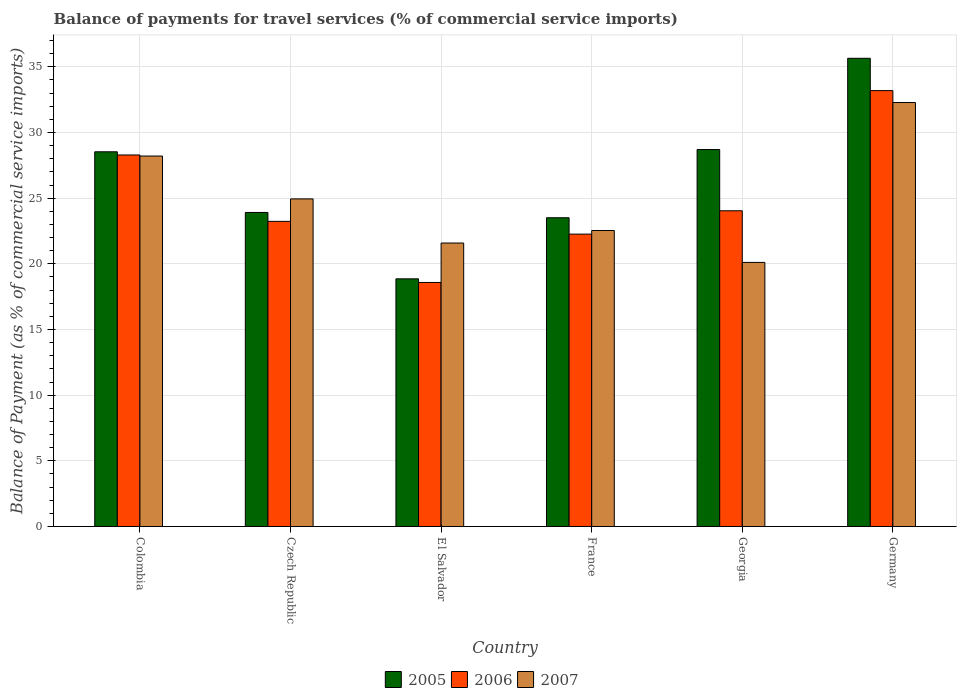How many different coloured bars are there?
Keep it short and to the point. 3. Are the number of bars per tick equal to the number of legend labels?
Provide a succinct answer. Yes. Are the number of bars on each tick of the X-axis equal?
Give a very brief answer. Yes. How many bars are there on the 3rd tick from the left?
Your response must be concise. 3. How many bars are there on the 3rd tick from the right?
Keep it short and to the point. 3. What is the label of the 3rd group of bars from the left?
Make the answer very short. El Salvador. What is the balance of payments for travel services in 2007 in Colombia?
Keep it short and to the point. 28.21. Across all countries, what is the maximum balance of payments for travel services in 2006?
Your answer should be compact. 33.19. Across all countries, what is the minimum balance of payments for travel services in 2005?
Ensure brevity in your answer.  18.86. In which country was the balance of payments for travel services in 2006 minimum?
Offer a terse response. El Salvador. What is the total balance of payments for travel services in 2005 in the graph?
Give a very brief answer. 159.16. What is the difference between the balance of payments for travel services in 2007 in France and that in Germany?
Provide a short and direct response. -9.75. What is the difference between the balance of payments for travel services in 2006 in Georgia and the balance of payments for travel services in 2005 in El Salvador?
Provide a short and direct response. 5.18. What is the average balance of payments for travel services in 2005 per country?
Your answer should be compact. 26.53. What is the difference between the balance of payments for travel services of/in 2007 and balance of payments for travel services of/in 2006 in El Salvador?
Your answer should be compact. 3. In how many countries, is the balance of payments for travel services in 2005 greater than 14 %?
Provide a succinct answer. 6. What is the ratio of the balance of payments for travel services in 2006 in Czech Republic to that in El Salvador?
Offer a terse response. 1.25. Is the difference between the balance of payments for travel services in 2007 in Colombia and El Salvador greater than the difference between the balance of payments for travel services in 2006 in Colombia and El Salvador?
Offer a very short reply. No. What is the difference between the highest and the second highest balance of payments for travel services in 2007?
Keep it short and to the point. 7.34. What is the difference between the highest and the lowest balance of payments for travel services in 2005?
Give a very brief answer. 16.79. In how many countries, is the balance of payments for travel services in 2005 greater than the average balance of payments for travel services in 2005 taken over all countries?
Your answer should be compact. 3. What does the 1st bar from the left in Germany represents?
Offer a terse response. 2005. Is it the case that in every country, the sum of the balance of payments for travel services in 2006 and balance of payments for travel services in 2007 is greater than the balance of payments for travel services in 2005?
Your answer should be compact. Yes. Are all the bars in the graph horizontal?
Offer a very short reply. No. What is the difference between two consecutive major ticks on the Y-axis?
Ensure brevity in your answer.  5. Are the values on the major ticks of Y-axis written in scientific E-notation?
Ensure brevity in your answer.  No. Does the graph contain any zero values?
Your answer should be very brief. No. What is the title of the graph?
Provide a short and direct response. Balance of payments for travel services (% of commercial service imports). What is the label or title of the X-axis?
Your response must be concise. Country. What is the label or title of the Y-axis?
Give a very brief answer. Balance of Payment (as % of commercial service imports). What is the Balance of Payment (as % of commercial service imports) of 2005 in Colombia?
Your answer should be very brief. 28.53. What is the Balance of Payment (as % of commercial service imports) in 2006 in Colombia?
Keep it short and to the point. 28.29. What is the Balance of Payment (as % of commercial service imports) in 2007 in Colombia?
Provide a short and direct response. 28.21. What is the Balance of Payment (as % of commercial service imports) of 2005 in Czech Republic?
Give a very brief answer. 23.91. What is the Balance of Payment (as % of commercial service imports) in 2006 in Czech Republic?
Keep it short and to the point. 23.24. What is the Balance of Payment (as % of commercial service imports) of 2007 in Czech Republic?
Make the answer very short. 24.94. What is the Balance of Payment (as % of commercial service imports) of 2005 in El Salvador?
Offer a very short reply. 18.86. What is the Balance of Payment (as % of commercial service imports) in 2006 in El Salvador?
Offer a terse response. 18.58. What is the Balance of Payment (as % of commercial service imports) of 2007 in El Salvador?
Keep it short and to the point. 21.59. What is the Balance of Payment (as % of commercial service imports) in 2005 in France?
Offer a terse response. 23.51. What is the Balance of Payment (as % of commercial service imports) of 2006 in France?
Your answer should be compact. 22.26. What is the Balance of Payment (as % of commercial service imports) in 2007 in France?
Your answer should be very brief. 22.54. What is the Balance of Payment (as % of commercial service imports) of 2005 in Georgia?
Provide a short and direct response. 28.7. What is the Balance of Payment (as % of commercial service imports) in 2006 in Georgia?
Offer a very short reply. 24.04. What is the Balance of Payment (as % of commercial service imports) of 2007 in Georgia?
Offer a very short reply. 20.11. What is the Balance of Payment (as % of commercial service imports) of 2005 in Germany?
Give a very brief answer. 35.65. What is the Balance of Payment (as % of commercial service imports) in 2006 in Germany?
Make the answer very short. 33.19. What is the Balance of Payment (as % of commercial service imports) in 2007 in Germany?
Your answer should be compact. 32.28. Across all countries, what is the maximum Balance of Payment (as % of commercial service imports) of 2005?
Offer a very short reply. 35.65. Across all countries, what is the maximum Balance of Payment (as % of commercial service imports) of 2006?
Your answer should be compact. 33.19. Across all countries, what is the maximum Balance of Payment (as % of commercial service imports) of 2007?
Offer a very short reply. 32.28. Across all countries, what is the minimum Balance of Payment (as % of commercial service imports) of 2005?
Give a very brief answer. 18.86. Across all countries, what is the minimum Balance of Payment (as % of commercial service imports) in 2006?
Give a very brief answer. 18.58. Across all countries, what is the minimum Balance of Payment (as % of commercial service imports) in 2007?
Provide a succinct answer. 20.11. What is the total Balance of Payment (as % of commercial service imports) of 2005 in the graph?
Offer a terse response. 159.16. What is the total Balance of Payment (as % of commercial service imports) of 2006 in the graph?
Provide a succinct answer. 149.6. What is the total Balance of Payment (as % of commercial service imports) in 2007 in the graph?
Keep it short and to the point. 149.67. What is the difference between the Balance of Payment (as % of commercial service imports) of 2005 in Colombia and that in Czech Republic?
Your answer should be very brief. 4.62. What is the difference between the Balance of Payment (as % of commercial service imports) of 2006 in Colombia and that in Czech Republic?
Offer a terse response. 5.05. What is the difference between the Balance of Payment (as % of commercial service imports) in 2007 in Colombia and that in Czech Republic?
Make the answer very short. 3.26. What is the difference between the Balance of Payment (as % of commercial service imports) of 2005 in Colombia and that in El Salvador?
Give a very brief answer. 9.67. What is the difference between the Balance of Payment (as % of commercial service imports) in 2006 in Colombia and that in El Salvador?
Keep it short and to the point. 9.71. What is the difference between the Balance of Payment (as % of commercial service imports) of 2007 in Colombia and that in El Salvador?
Your answer should be very brief. 6.62. What is the difference between the Balance of Payment (as % of commercial service imports) of 2005 in Colombia and that in France?
Offer a very short reply. 5.02. What is the difference between the Balance of Payment (as % of commercial service imports) of 2006 in Colombia and that in France?
Your answer should be compact. 6.03. What is the difference between the Balance of Payment (as % of commercial service imports) of 2007 in Colombia and that in France?
Your answer should be compact. 5.67. What is the difference between the Balance of Payment (as % of commercial service imports) in 2005 in Colombia and that in Georgia?
Keep it short and to the point. -0.17. What is the difference between the Balance of Payment (as % of commercial service imports) in 2006 in Colombia and that in Georgia?
Offer a very short reply. 4.25. What is the difference between the Balance of Payment (as % of commercial service imports) of 2007 in Colombia and that in Georgia?
Ensure brevity in your answer.  8.1. What is the difference between the Balance of Payment (as % of commercial service imports) in 2005 in Colombia and that in Germany?
Make the answer very short. -7.12. What is the difference between the Balance of Payment (as % of commercial service imports) in 2006 in Colombia and that in Germany?
Your response must be concise. -4.9. What is the difference between the Balance of Payment (as % of commercial service imports) in 2007 in Colombia and that in Germany?
Make the answer very short. -4.08. What is the difference between the Balance of Payment (as % of commercial service imports) of 2005 in Czech Republic and that in El Salvador?
Make the answer very short. 5.05. What is the difference between the Balance of Payment (as % of commercial service imports) in 2006 in Czech Republic and that in El Salvador?
Provide a short and direct response. 4.65. What is the difference between the Balance of Payment (as % of commercial service imports) of 2007 in Czech Republic and that in El Salvador?
Provide a short and direct response. 3.36. What is the difference between the Balance of Payment (as % of commercial service imports) of 2005 in Czech Republic and that in France?
Keep it short and to the point. 0.4. What is the difference between the Balance of Payment (as % of commercial service imports) in 2006 in Czech Republic and that in France?
Offer a terse response. 0.97. What is the difference between the Balance of Payment (as % of commercial service imports) in 2007 in Czech Republic and that in France?
Keep it short and to the point. 2.41. What is the difference between the Balance of Payment (as % of commercial service imports) of 2005 in Czech Republic and that in Georgia?
Your answer should be very brief. -4.79. What is the difference between the Balance of Payment (as % of commercial service imports) in 2006 in Czech Republic and that in Georgia?
Your answer should be compact. -0.8. What is the difference between the Balance of Payment (as % of commercial service imports) of 2007 in Czech Republic and that in Georgia?
Offer a terse response. 4.84. What is the difference between the Balance of Payment (as % of commercial service imports) in 2005 in Czech Republic and that in Germany?
Offer a very short reply. -11.74. What is the difference between the Balance of Payment (as % of commercial service imports) in 2006 in Czech Republic and that in Germany?
Your answer should be very brief. -9.96. What is the difference between the Balance of Payment (as % of commercial service imports) of 2007 in Czech Republic and that in Germany?
Keep it short and to the point. -7.34. What is the difference between the Balance of Payment (as % of commercial service imports) in 2005 in El Salvador and that in France?
Provide a succinct answer. -4.65. What is the difference between the Balance of Payment (as % of commercial service imports) in 2006 in El Salvador and that in France?
Your response must be concise. -3.68. What is the difference between the Balance of Payment (as % of commercial service imports) of 2007 in El Salvador and that in France?
Give a very brief answer. -0.95. What is the difference between the Balance of Payment (as % of commercial service imports) in 2005 in El Salvador and that in Georgia?
Give a very brief answer. -9.85. What is the difference between the Balance of Payment (as % of commercial service imports) of 2006 in El Salvador and that in Georgia?
Offer a very short reply. -5.46. What is the difference between the Balance of Payment (as % of commercial service imports) of 2007 in El Salvador and that in Georgia?
Offer a terse response. 1.48. What is the difference between the Balance of Payment (as % of commercial service imports) in 2005 in El Salvador and that in Germany?
Offer a very short reply. -16.79. What is the difference between the Balance of Payment (as % of commercial service imports) in 2006 in El Salvador and that in Germany?
Ensure brevity in your answer.  -14.61. What is the difference between the Balance of Payment (as % of commercial service imports) in 2007 in El Salvador and that in Germany?
Your answer should be very brief. -10.7. What is the difference between the Balance of Payment (as % of commercial service imports) of 2005 in France and that in Georgia?
Keep it short and to the point. -5.19. What is the difference between the Balance of Payment (as % of commercial service imports) in 2006 in France and that in Georgia?
Provide a succinct answer. -1.78. What is the difference between the Balance of Payment (as % of commercial service imports) in 2007 in France and that in Georgia?
Your response must be concise. 2.43. What is the difference between the Balance of Payment (as % of commercial service imports) in 2005 in France and that in Germany?
Provide a succinct answer. -12.14. What is the difference between the Balance of Payment (as % of commercial service imports) in 2006 in France and that in Germany?
Provide a succinct answer. -10.93. What is the difference between the Balance of Payment (as % of commercial service imports) of 2007 in France and that in Germany?
Your response must be concise. -9.75. What is the difference between the Balance of Payment (as % of commercial service imports) of 2005 in Georgia and that in Germany?
Give a very brief answer. -6.95. What is the difference between the Balance of Payment (as % of commercial service imports) in 2006 in Georgia and that in Germany?
Your answer should be compact. -9.15. What is the difference between the Balance of Payment (as % of commercial service imports) of 2007 in Georgia and that in Germany?
Your answer should be very brief. -12.18. What is the difference between the Balance of Payment (as % of commercial service imports) in 2005 in Colombia and the Balance of Payment (as % of commercial service imports) in 2006 in Czech Republic?
Offer a terse response. 5.3. What is the difference between the Balance of Payment (as % of commercial service imports) of 2005 in Colombia and the Balance of Payment (as % of commercial service imports) of 2007 in Czech Republic?
Your response must be concise. 3.59. What is the difference between the Balance of Payment (as % of commercial service imports) of 2006 in Colombia and the Balance of Payment (as % of commercial service imports) of 2007 in Czech Republic?
Keep it short and to the point. 3.34. What is the difference between the Balance of Payment (as % of commercial service imports) in 2005 in Colombia and the Balance of Payment (as % of commercial service imports) in 2006 in El Salvador?
Offer a terse response. 9.95. What is the difference between the Balance of Payment (as % of commercial service imports) in 2005 in Colombia and the Balance of Payment (as % of commercial service imports) in 2007 in El Salvador?
Offer a very short reply. 6.95. What is the difference between the Balance of Payment (as % of commercial service imports) of 2006 in Colombia and the Balance of Payment (as % of commercial service imports) of 2007 in El Salvador?
Ensure brevity in your answer.  6.7. What is the difference between the Balance of Payment (as % of commercial service imports) in 2005 in Colombia and the Balance of Payment (as % of commercial service imports) in 2006 in France?
Offer a terse response. 6.27. What is the difference between the Balance of Payment (as % of commercial service imports) in 2005 in Colombia and the Balance of Payment (as % of commercial service imports) in 2007 in France?
Give a very brief answer. 5.99. What is the difference between the Balance of Payment (as % of commercial service imports) in 2006 in Colombia and the Balance of Payment (as % of commercial service imports) in 2007 in France?
Offer a terse response. 5.75. What is the difference between the Balance of Payment (as % of commercial service imports) in 2005 in Colombia and the Balance of Payment (as % of commercial service imports) in 2006 in Georgia?
Make the answer very short. 4.49. What is the difference between the Balance of Payment (as % of commercial service imports) of 2005 in Colombia and the Balance of Payment (as % of commercial service imports) of 2007 in Georgia?
Make the answer very short. 8.42. What is the difference between the Balance of Payment (as % of commercial service imports) in 2006 in Colombia and the Balance of Payment (as % of commercial service imports) in 2007 in Georgia?
Ensure brevity in your answer.  8.18. What is the difference between the Balance of Payment (as % of commercial service imports) in 2005 in Colombia and the Balance of Payment (as % of commercial service imports) in 2006 in Germany?
Make the answer very short. -4.66. What is the difference between the Balance of Payment (as % of commercial service imports) of 2005 in Colombia and the Balance of Payment (as % of commercial service imports) of 2007 in Germany?
Keep it short and to the point. -3.75. What is the difference between the Balance of Payment (as % of commercial service imports) in 2006 in Colombia and the Balance of Payment (as % of commercial service imports) in 2007 in Germany?
Provide a succinct answer. -3.99. What is the difference between the Balance of Payment (as % of commercial service imports) in 2005 in Czech Republic and the Balance of Payment (as % of commercial service imports) in 2006 in El Salvador?
Your answer should be compact. 5.33. What is the difference between the Balance of Payment (as % of commercial service imports) in 2005 in Czech Republic and the Balance of Payment (as % of commercial service imports) in 2007 in El Salvador?
Provide a succinct answer. 2.33. What is the difference between the Balance of Payment (as % of commercial service imports) in 2006 in Czech Republic and the Balance of Payment (as % of commercial service imports) in 2007 in El Salvador?
Provide a short and direct response. 1.65. What is the difference between the Balance of Payment (as % of commercial service imports) of 2005 in Czech Republic and the Balance of Payment (as % of commercial service imports) of 2006 in France?
Provide a short and direct response. 1.65. What is the difference between the Balance of Payment (as % of commercial service imports) in 2005 in Czech Republic and the Balance of Payment (as % of commercial service imports) in 2007 in France?
Give a very brief answer. 1.37. What is the difference between the Balance of Payment (as % of commercial service imports) in 2006 in Czech Republic and the Balance of Payment (as % of commercial service imports) in 2007 in France?
Make the answer very short. 0.7. What is the difference between the Balance of Payment (as % of commercial service imports) of 2005 in Czech Republic and the Balance of Payment (as % of commercial service imports) of 2006 in Georgia?
Your answer should be compact. -0.13. What is the difference between the Balance of Payment (as % of commercial service imports) in 2005 in Czech Republic and the Balance of Payment (as % of commercial service imports) in 2007 in Georgia?
Keep it short and to the point. 3.8. What is the difference between the Balance of Payment (as % of commercial service imports) of 2006 in Czech Republic and the Balance of Payment (as % of commercial service imports) of 2007 in Georgia?
Your response must be concise. 3.13. What is the difference between the Balance of Payment (as % of commercial service imports) in 2005 in Czech Republic and the Balance of Payment (as % of commercial service imports) in 2006 in Germany?
Make the answer very short. -9.28. What is the difference between the Balance of Payment (as % of commercial service imports) in 2005 in Czech Republic and the Balance of Payment (as % of commercial service imports) in 2007 in Germany?
Your answer should be compact. -8.37. What is the difference between the Balance of Payment (as % of commercial service imports) of 2006 in Czech Republic and the Balance of Payment (as % of commercial service imports) of 2007 in Germany?
Provide a short and direct response. -9.05. What is the difference between the Balance of Payment (as % of commercial service imports) in 2005 in El Salvador and the Balance of Payment (as % of commercial service imports) in 2006 in France?
Make the answer very short. -3.41. What is the difference between the Balance of Payment (as % of commercial service imports) in 2005 in El Salvador and the Balance of Payment (as % of commercial service imports) in 2007 in France?
Your response must be concise. -3.68. What is the difference between the Balance of Payment (as % of commercial service imports) in 2006 in El Salvador and the Balance of Payment (as % of commercial service imports) in 2007 in France?
Your answer should be very brief. -3.96. What is the difference between the Balance of Payment (as % of commercial service imports) of 2005 in El Salvador and the Balance of Payment (as % of commercial service imports) of 2006 in Georgia?
Your answer should be compact. -5.18. What is the difference between the Balance of Payment (as % of commercial service imports) in 2005 in El Salvador and the Balance of Payment (as % of commercial service imports) in 2007 in Georgia?
Make the answer very short. -1.25. What is the difference between the Balance of Payment (as % of commercial service imports) of 2006 in El Salvador and the Balance of Payment (as % of commercial service imports) of 2007 in Georgia?
Your answer should be compact. -1.53. What is the difference between the Balance of Payment (as % of commercial service imports) of 2005 in El Salvador and the Balance of Payment (as % of commercial service imports) of 2006 in Germany?
Offer a very short reply. -14.33. What is the difference between the Balance of Payment (as % of commercial service imports) of 2005 in El Salvador and the Balance of Payment (as % of commercial service imports) of 2007 in Germany?
Your response must be concise. -13.43. What is the difference between the Balance of Payment (as % of commercial service imports) in 2006 in El Salvador and the Balance of Payment (as % of commercial service imports) in 2007 in Germany?
Your answer should be very brief. -13.7. What is the difference between the Balance of Payment (as % of commercial service imports) in 2005 in France and the Balance of Payment (as % of commercial service imports) in 2006 in Georgia?
Ensure brevity in your answer.  -0.53. What is the difference between the Balance of Payment (as % of commercial service imports) of 2005 in France and the Balance of Payment (as % of commercial service imports) of 2007 in Georgia?
Offer a very short reply. 3.4. What is the difference between the Balance of Payment (as % of commercial service imports) in 2006 in France and the Balance of Payment (as % of commercial service imports) in 2007 in Georgia?
Your answer should be compact. 2.15. What is the difference between the Balance of Payment (as % of commercial service imports) of 2005 in France and the Balance of Payment (as % of commercial service imports) of 2006 in Germany?
Give a very brief answer. -9.68. What is the difference between the Balance of Payment (as % of commercial service imports) of 2005 in France and the Balance of Payment (as % of commercial service imports) of 2007 in Germany?
Keep it short and to the point. -8.77. What is the difference between the Balance of Payment (as % of commercial service imports) of 2006 in France and the Balance of Payment (as % of commercial service imports) of 2007 in Germany?
Your response must be concise. -10.02. What is the difference between the Balance of Payment (as % of commercial service imports) in 2005 in Georgia and the Balance of Payment (as % of commercial service imports) in 2006 in Germany?
Give a very brief answer. -4.49. What is the difference between the Balance of Payment (as % of commercial service imports) of 2005 in Georgia and the Balance of Payment (as % of commercial service imports) of 2007 in Germany?
Provide a succinct answer. -3.58. What is the difference between the Balance of Payment (as % of commercial service imports) in 2006 in Georgia and the Balance of Payment (as % of commercial service imports) in 2007 in Germany?
Offer a terse response. -8.24. What is the average Balance of Payment (as % of commercial service imports) of 2005 per country?
Your response must be concise. 26.53. What is the average Balance of Payment (as % of commercial service imports) in 2006 per country?
Keep it short and to the point. 24.93. What is the average Balance of Payment (as % of commercial service imports) in 2007 per country?
Your answer should be compact. 24.94. What is the difference between the Balance of Payment (as % of commercial service imports) of 2005 and Balance of Payment (as % of commercial service imports) of 2006 in Colombia?
Ensure brevity in your answer.  0.24. What is the difference between the Balance of Payment (as % of commercial service imports) in 2005 and Balance of Payment (as % of commercial service imports) in 2007 in Colombia?
Your answer should be compact. 0.32. What is the difference between the Balance of Payment (as % of commercial service imports) of 2006 and Balance of Payment (as % of commercial service imports) of 2007 in Colombia?
Your answer should be compact. 0.08. What is the difference between the Balance of Payment (as % of commercial service imports) in 2005 and Balance of Payment (as % of commercial service imports) in 2006 in Czech Republic?
Offer a terse response. 0.68. What is the difference between the Balance of Payment (as % of commercial service imports) in 2005 and Balance of Payment (as % of commercial service imports) in 2007 in Czech Republic?
Ensure brevity in your answer.  -1.03. What is the difference between the Balance of Payment (as % of commercial service imports) of 2006 and Balance of Payment (as % of commercial service imports) of 2007 in Czech Republic?
Offer a terse response. -1.71. What is the difference between the Balance of Payment (as % of commercial service imports) of 2005 and Balance of Payment (as % of commercial service imports) of 2006 in El Salvador?
Keep it short and to the point. 0.28. What is the difference between the Balance of Payment (as % of commercial service imports) of 2005 and Balance of Payment (as % of commercial service imports) of 2007 in El Salvador?
Your answer should be very brief. -2.73. What is the difference between the Balance of Payment (as % of commercial service imports) in 2006 and Balance of Payment (as % of commercial service imports) in 2007 in El Salvador?
Offer a very short reply. -3. What is the difference between the Balance of Payment (as % of commercial service imports) of 2005 and Balance of Payment (as % of commercial service imports) of 2006 in France?
Offer a terse response. 1.25. What is the difference between the Balance of Payment (as % of commercial service imports) of 2005 and Balance of Payment (as % of commercial service imports) of 2007 in France?
Ensure brevity in your answer.  0.97. What is the difference between the Balance of Payment (as % of commercial service imports) of 2006 and Balance of Payment (as % of commercial service imports) of 2007 in France?
Your answer should be compact. -0.27. What is the difference between the Balance of Payment (as % of commercial service imports) of 2005 and Balance of Payment (as % of commercial service imports) of 2006 in Georgia?
Your response must be concise. 4.66. What is the difference between the Balance of Payment (as % of commercial service imports) in 2005 and Balance of Payment (as % of commercial service imports) in 2007 in Georgia?
Keep it short and to the point. 8.59. What is the difference between the Balance of Payment (as % of commercial service imports) in 2006 and Balance of Payment (as % of commercial service imports) in 2007 in Georgia?
Make the answer very short. 3.93. What is the difference between the Balance of Payment (as % of commercial service imports) in 2005 and Balance of Payment (as % of commercial service imports) in 2006 in Germany?
Provide a succinct answer. 2.46. What is the difference between the Balance of Payment (as % of commercial service imports) of 2005 and Balance of Payment (as % of commercial service imports) of 2007 in Germany?
Offer a very short reply. 3.37. What is the difference between the Balance of Payment (as % of commercial service imports) in 2006 and Balance of Payment (as % of commercial service imports) in 2007 in Germany?
Ensure brevity in your answer.  0.91. What is the ratio of the Balance of Payment (as % of commercial service imports) of 2005 in Colombia to that in Czech Republic?
Provide a short and direct response. 1.19. What is the ratio of the Balance of Payment (as % of commercial service imports) in 2006 in Colombia to that in Czech Republic?
Offer a very short reply. 1.22. What is the ratio of the Balance of Payment (as % of commercial service imports) of 2007 in Colombia to that in Czech Republic?
Your response must be concise. 1.13. What is the ratio of the Balance of Payment (as % of commercial service imports) of 2005 in Colombia to that in El Salvador?
Your answer should be compact. 1.51. What is the ratio of the Balance of Payment (as % of commercial service imports) of 2006 in Colombia to that in El Salvador?
Give a very brief answer. 1.52. What is the ratio of the Balance of Payment (as % of commercial service imports) in 2007 in Colombia to that in El Salvador?
Provide a short and direct response. 1.31. What is the ratio of the Balance of Payment (as % of commercial service imports) of 2005 in Colombia to that in France?
Your answer should be very brief. 1.21. What is the ratio of the Balance of Payment (as % of commercial service imports) of 2006 in Colombia to that in France?
Your response must be concise. 1.27. What is the ratio of the Balance of Payment (as % of commercial service imports) in 2007 in Colombia to that in France?
Ensure brevity in your answer.  1.25. What is the ratio of the Balance of Payment (as % of commercial service imports) of 2005 in Colombia to that in Georgia?
Give a very brief answer. 0.99. What is the ratio of the Balance of Payment (as % of commercial service imports) in 2006 in Colombia to that in Georgia?
Provide a succinct answer. 1.18. What is the ratio of the Balance of Payment (as % of commercial service imports) in 2007 in Colombia to that in Georgia?
Offer a very short reply. 1.4. What is the ratio of the Balance of Payment (as % of commercial service imports) in 2005 in Colombia to that in Germany?
Offer a very short reply. 0.8. What is the ratio of the Balance of Payment (as % of commercial service imports) in 2006 in Colombia to that in Germany?
Ensure brevity in your answer.  0.85. What is the ratio of the Balance of Payment (as % of commercial service imports) of 2007 in Colombia to that in Germany?
Give a very brief answer. 0.87. What is the ratio of the Balance of Payment (as % of commercial service imports) of 2005 in Czech Republic to that in El Salvador?
Your answer should be very brief. 1.27. What is the ratio of the Balance of Payment (as % of commercial service imports) of 2006 in Czech Republic to that in El Salvador?
Ensure brevity in your answer.  1.25. What is the ratio of the Balance of Payment (as % of commercial service imports) of 2007 in Czech Republic to that in El Salvador?
Provide a short and direct response. 1.16. What is the ratio of the Balance of Payment (as % of commercial service imports) in 2005 in Czech Republic to that in France?
Offer a terse response. 1.02. What is the ratio of the Balance of Payment (as % of commercial service imports) of 2006 in Czech Republic to that in France?
Make the answer very short. 1.04. What is the ratio of the Balance of Payment (as % of commercial service imports) of 2007 in Czech Republic to that in France?
Offer a very short reply. 1.11. What is the ratio of the Balance of Payment (as % of commercial service imports) in 2005 in Czech Republic to that in Georgia?
Your answer should be very brief. 0.83. What is the ratio of the Balance of Payment (as % of commercial service imports) of 2006 in Czech Republic to that in Georgia?
Provide a succinct answer. 0.97. What is the ratio of the Balance of Payment (as % of commercial service imports) in 2007 in Czech Republic to that in Georgia?
Your response must be concise. 1.24. What is the ratio of the Balance of Payment (as % of commercial service imports) in 2005 in Czech Republic to that in Germany?
Offer a very short reply. 0.67. What is the ratio of the Balance of Payment (as % of commercial service imports) of 2006 in Czech Republic to that in Germany?
Provide a short and direct response. 0.7. What is the ratio of the Balance of Payment (as % of commercial service imports) in 2007 in Czech Republic to that in Germany?
Provide a short and direct response. 0.77. What is the ratio of the Balance of Payment (as % of commercial service imports) of 2005 in El Salvador to that in France?
Your response must be concise. 0.8. What is the ratio of the Balance of Payment (as % of commercial service imports) of 2006 in El Salvador to that in France?
Make the answer very short. 0.83. What is the ratio of the Balance of Payment (as % of commercial service imports) in 2007 in El Salvador to that in France?
Your answer should be compact. 0.96. What is the ratio of the Balance of Payment (as % of commercial service imports) in 2005 in El Salvador to that in Georgia?
Your answer should be compact. 0.66. What is the ratio of the Balance of Payment (as % of commercial service imports) of 2006 in El Salvador to that in Georgia?
Offer a very short reply. 0.77. What is the ratio of the Balance of Payment (as % of commercial service imports) of 2007 in El Salvador to that in Georgia?
Your answer should be very brief. 1.07. What is the ratio of the Balance of Payment (as % of commercial service imports) in 2005 in El Salvador to that in Germany?
Give a very brief answer. 0.53. What is the ratio of the Balance of Payment (as % of commercial service imports) of 2006 in El Salvador to that in Germany?
Offer a terse response. 0.56. What is the ratio of the Balance of Payment (as % of commercial service imports) of 2007 in El Salvador to that in Germany?
Your answer should be compact. 0.67. What is the ratio of the Balance of Payment (as % of commercial service imports) in 2005 in France to that in Georgia?
Keep it short and to the point. 0.82. What is the ratio of the Balance of Payment (as % of commercial service imports) in 2006 in France to that in Georgia?
Give a very brief answer. 0.93. What is the ratio of the Balance of Payment (as % of commercial service imports) of 2007 in France to that in Georgia?
Your answer should be very brief. 1.12. What is the ratio of the Balance of Payment (as % of commercial service imports) of 2005 in France to that in Germany?
Offer a terse response. 0.66. What is the ratio of the Balance of Payment (as % of commercial service imports) of 2006 in France to that in Germany?
Keep it short and to the point. 0.67. What is the ratio of the Balance of Payment (as % of commercial service imports) in 2007 in France to that in Germany?
Provide a succinct answer. 0.7. What is the ratio of the Balance of Payment (as % of commercial service imports) of 2005 in Georgia to that in Germany?
Ensure brevity in your answer.  0.81. What is the ratio of the Balance of Payment (as % of commercial service imports) in 2006 in Georgia to that in Germany?
Give a very brief answer. 0.72. What is the ratio of the Balance of Payment (as % of commercial service imports) in 2007 in Georgia to that in Germany?
Make the answer very short. 0.62. What is the difference between the highest and the second highest Balance of Payment (as % of commercial service imports) of 2005?
Offer a terse response. 6.95. What is the difference between the highest and the second highest Balance of Payment (as % of commercial service imports) of 2006?
Your answer should be compact. 4.9. What is the difference between the highest and the second highest Balance of Payment (as % of commercial service imports) in 2007?
Ensure brevity in your answer.  4.08. What is the difference between the highest and the lowest Balance of Payment (as % of commercial service imports) of 2005?
Provide a succinct answer. 16.79. What is the difference between the highest and the lowest Balance of Payment (as % of commercial service imports) of 2006?
Provide a succinct answer. 14.61. What is the difference between the highest and the lowest Balance of Payment (as % of commercial service imports) in 2007?
Your response must be concise. 12.18. 